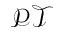<formula> <loc_0><loc_0><loc_500><loc_500>\mathcal { P T }</formula> 